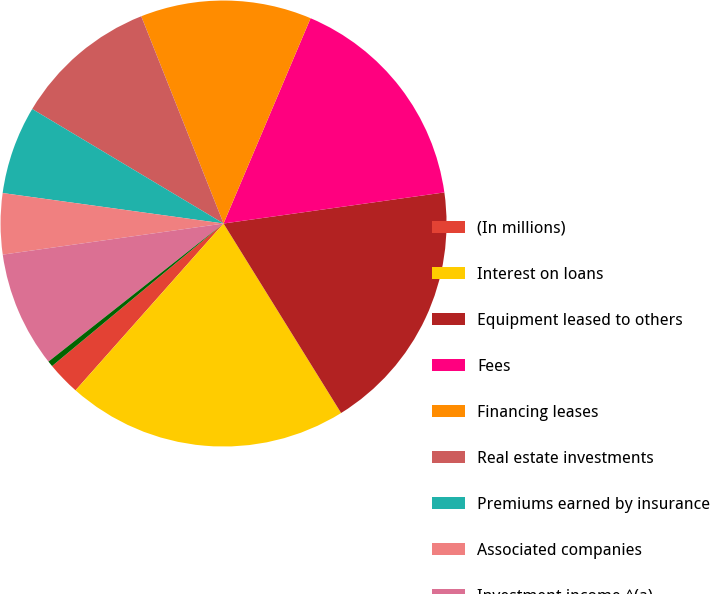Convert chart. <chart><loc_0><loc_0><loc_500><loc_500><pie_chart><fcel>(In millions)<fcel>Interest on loans<fcel>Equipment leased to others<fcel>Fees<fcel>Financing leases<fcel>Real estate investments<fcel>Premiums earned by insurance<fcel>Associated companies<fcel>Investment income ^(a)<fcel>Net securitization gains<nl><fcel>2.41%<fcel>20.39%<fcel>18.39%<fcel>16.39%<fcel>12.4%<fcel>10.4%<fcel>6.4%<fcel>4.41%<fcel>8.4%<fcel>0.41%<nl></chart> 